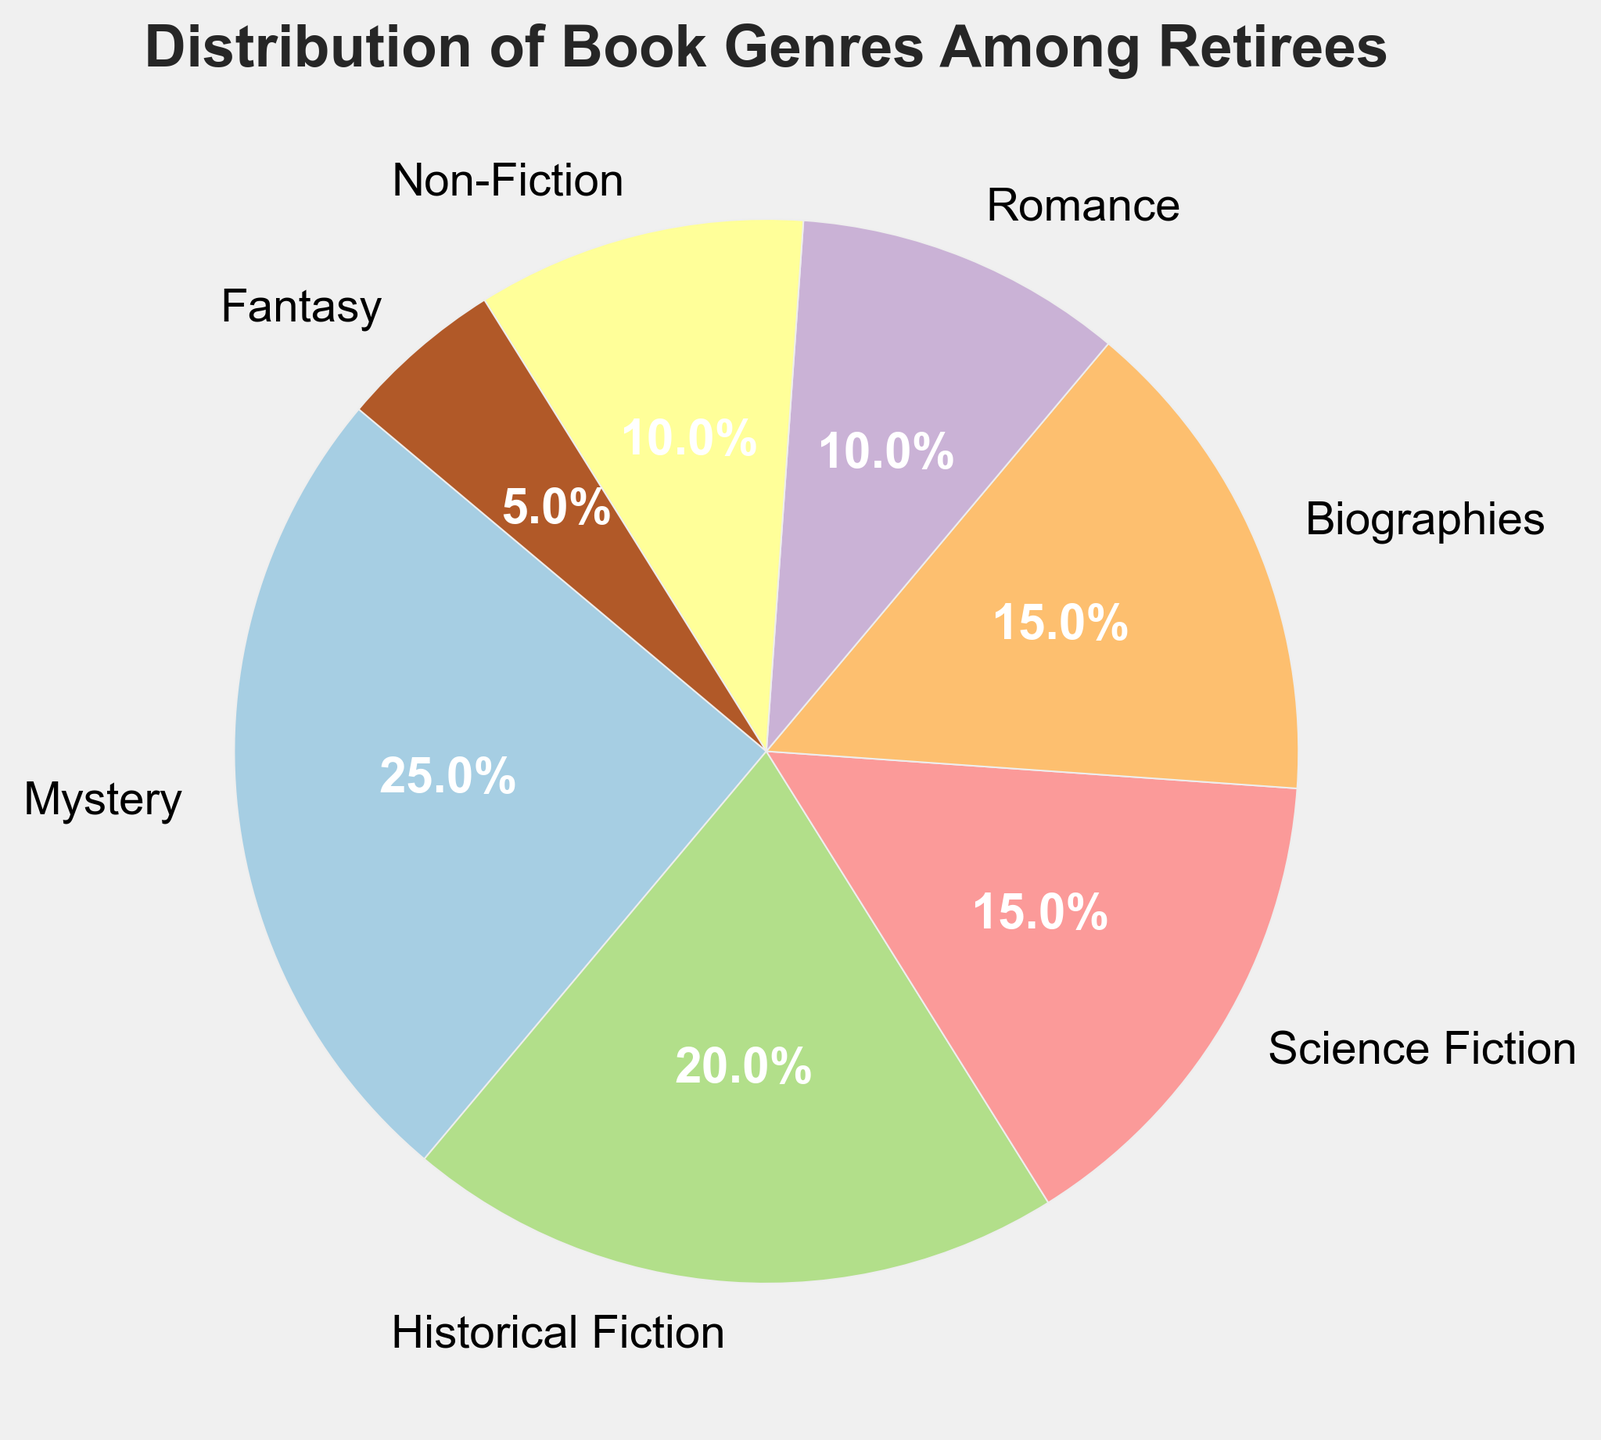What genre has the highest percentage among retirees? Look at the pie chart and identify the genre with the largest slice. The Mystery genre has the highest percentage at 25%.
Answer: Mystery Which genre has the lowest percentage among retirees? Check the slices of the pie chart to find the smallest one. The Fantasy genre has the lowest percentage at 5%.
Answer: Fantasy What is the combined percentage of retirees who prefer Science Fiction and Biographies? Locate the slices for Science Fiction and Biographies on the pie chart. Science Fiction is 15% and Biographies is 15%. Add them together: 15% + 15% = 30%.
Answer: 30% Is the percentage of retirees who prefer Mystery greater than those who prefer Non-Fiction? Compare the slices for Mystery and Non-Fiction genres. Mystery is at 25% while Non-Fiction is at 10%. 25% is greater than 10%.
Answer: Yes How much higher is the percentage of retirees who prefer Historical Fiction compared to Romance? Identify the percentages for Historical Fiction and Romance on the pie chart. Historical Fiction is 20% and Romance is 10%. Subtract Romance's percentage from Historical Fiction's: 20% - 10% = 10%.
Answer: 10% Which genres have a percentage that is equal among retirees? Check the pie chart for genres with the same size slices. Both Science Fiction and Biographies are at 15%.
Answer: Science Fiction, Biographies What is the total percentage of retirees who prefer Fantasy or Non-Fiction genres? Locate the slices for Fantasy and Non-Fiction on the pie chart. Fantasy is 5% and Non-Fiction is 10%. Add them together: 5% + 10% = 15%.
Answer: 15% What percentage of retirees prefer either Mystery, Historical Fiction, or Fantasy? Find the slices for Mystery, Historical Fiction, and Fantasy on the pie chart. Mystery is 25%, Historical Fiction is 20%, Fantasy is 5%. Add them together: 25% + 20% + 5% = 50%.
Answer: 50% Compare the combined percentage of Biographies and Romance to Mystery. Which is higher? Find the slices for Biographies, Romance, and Mystery on the pie chart. Biographies (15%) plus Romance (10%) equals 25%. Mystery is also 25%. 25% is equal to 25%.
Answer: Equal What is the average percentage of the genres Mystery, Historical Fiction, and Science Fiction? Find the slices for Mystery, Historical Fiction, and Science Fiction on the pie chart. Mystery is 25%, Historical Fiction is 20%, Science Fiction is 15%. Add them together and divide by the number of genres: (25% + 20% + 15%) / 3 = 60% / 3 = 20%.
Answer: 20% 